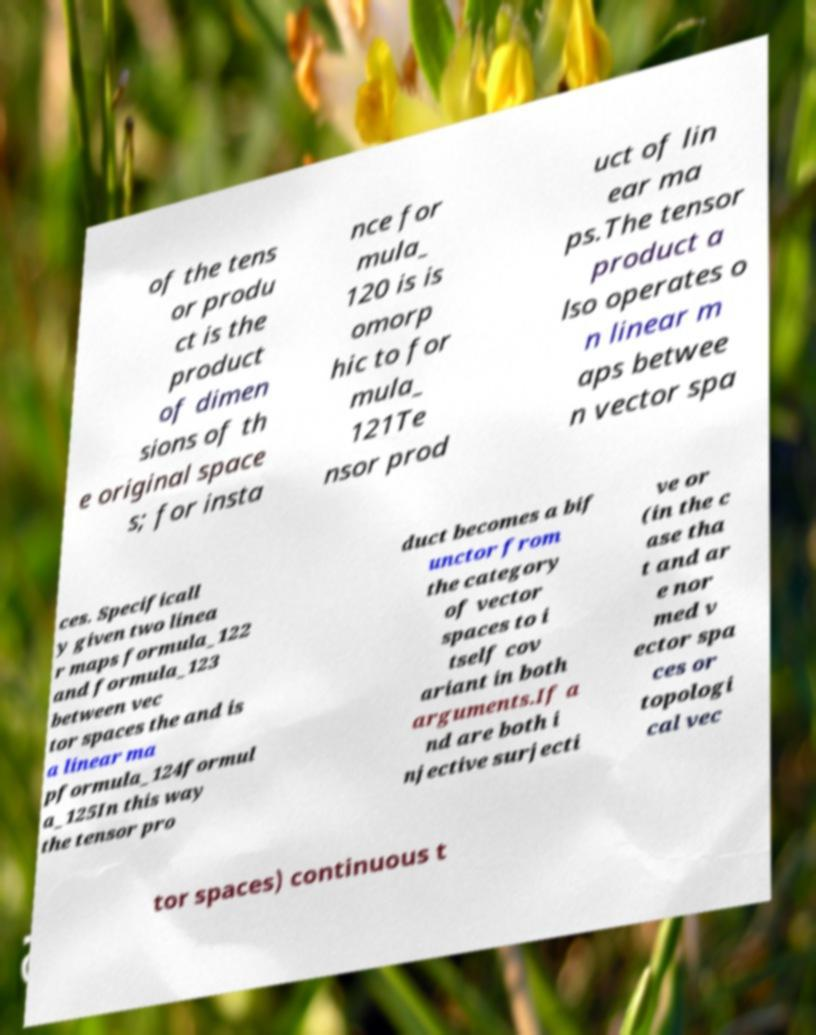Could you assist in decoding the text presented in this image and type it out clearly? of the tens or produ ct is the product of dimen sions of th e original space s; for insta nce for mula_ 120 is is omorp hic to for mula_ 121Te nsor prod uct of lin ear ma ps.The tensor product a lso operates o n linear m aps betwee n vector spa ces. Specificall y given two linea r maps formula_122 and formula_123 between vec tor spaces the and is a linear ma pformula_124formul a_125In this way the tensor pro duct becomes a bif unctor from the category of vector spaces to i tself cov ariant in both arguments.If a nd are both i njective surjecti ve or (in the c ase tha t and ar e nor med v ector spa ces or topologi cal vec tor spaces) continuous t 